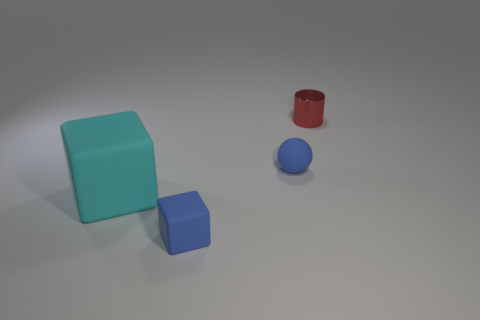There is a block that is behind the blue rubber thing that is in front of the matte ball; what is its color?
Offer a very short reply. Cyan. Are there fewer shiny things than small gray cylinders?
Your answer should be very brief. No. How many other small matte objects have the same shape as the cyan rubber thing?
Offer a very short reply. 1. The metal thing that is the same size as the blue matte sphere is what color?
Your answer should be very brief. Red. Is the number of tiny matte things that are behind the metallic object the same as the number of big matte blocks on the right side of the small blue matte sphere?
Offer a very short reply. Yes. Are there any red things of the same size as the metal cylinder?
Keep it short and to the point. No. The blue rubber block is what size?
Your answer should be very brief. Small. Are there the same number of large cyan cubes that are to the left of the large block and cylinders?
Your response must be concise. No. How many other things are there of the same color as the large rubber object?
Keep it short and to the point. 0. What color is the tiny object that is to the left of the small metal cylinder and behind the tiny blue rubber block?
Offer a very short reply. Blue. 